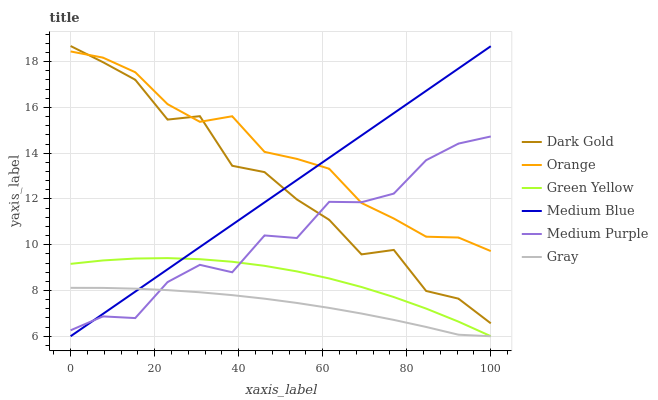Does Gray have the minimum area under the curve?
Answer yes or no. Yes. Does Orange have the maximum area under the curve?
Answer yes or no. Yes. Does Dark Gold have the minimum area under the curve?
Answer yes or no. No. Does Dark Gold have the maximum area under the curve?
Answer yes or no. No. Is Medium Blue the smoothest?
Answer yes or no. Yes. Is Dark Gold the roughest?
Answer yes or no. Yes. Is Dark Gold the smoothest?
Answer yes or no. No. Is Medium Blue the roughest?
Answer yes or no. No. Does Gray have the lowest value?
Answer yes or no. Yes. Does Dark Gold have the lowest value?
Answer yes or no. No. Does Dark Gold have the highest value?
Answer yes or no. Yes. Does Medium Blue have the highest value?
Answer yes or no. No. Is Gray less than Dark Gold?
Answer yes or no. Yes. Is Orange greater than Green Yellow?
Answer yes or no. Yes. Does Dark Gold intersect Medium Blue?
Answer yes or no. Yes. Is Dark Gold less than Medium Blue?
Answer yes or no. No. Is Dark Gold greater than Medium Blue?
Answer yes or no. No. Does Gray intersect Dark Gold?
Answer yes or no. No. 